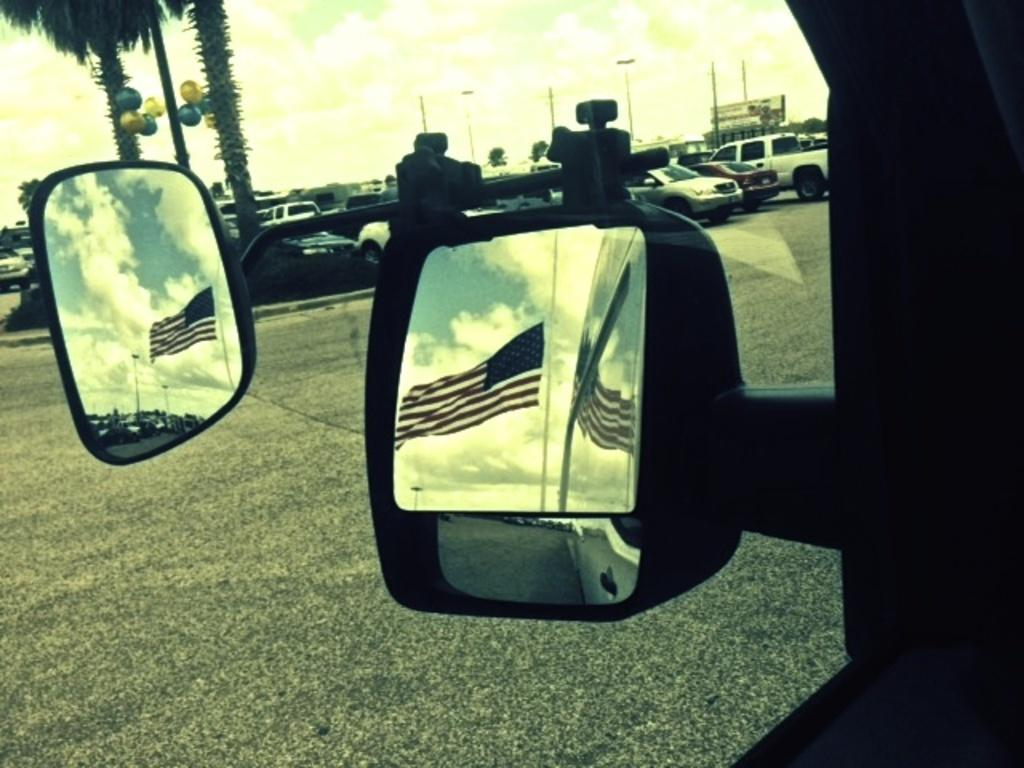What objects are located in the middle of the image? There are mirrors in the middle of the image. What do the mirrors reflect in the image? The mirrors reflect images of a flag in the image. What can be seen in the background of the image? There are cars and trees visible in the background of the image. What is visible at the top of the image? The sky is visible at the top of the image. What decision is being made by the page in the image? There is no page present in the image, so no decision can be made. 